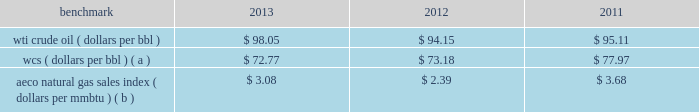Discount to brent was narrower in 2013 than in 2012 and 2011 .
As a result of the significant increase in u.s .
Production of light sweet crude oil , the historical relationship between wti , brent and lls pricing may not be indicative of future periods .
Composition 2013 the proportion of our liquid hydrocarbon sales volumes that are ngls continues to increase due to our development of united states unconventional liquids-rich plays .
Ngls were 15 percent of our north america e&p liquid hydrocarbon sales volumes in 2013 compared to 10 percent in 2012 and 7 percent in 2011 .
Natural gas 2013 a significant portion of our natural gas production in the u.s .
Is sold at bid-week prices , or first-of-month indices relative to our specific producing areas .
Average henry hub settlement prices for natural gas were 31 percent higher for 2013 than for 2012 .
International e&p liquid hydrocarbons 2013 our international e&p crude oil production is relatively sweet and has historically sold in relation to the brent crude benchmark , which on average was 3 percent lower for 2013 than 2012 .
Natural gas 2013 our major international e&p natural gas-producing regions are europe and e.g .
Natural gas prices in europe have been considerably higher than the u.s .
In recent years .
In the case of e.g. , our natural gas sales are subject to term contracts , making realized prices in these areas less volatile .
The natural gas sales from e.g .
Are at fixed prices ; therefore , our reported average international e&p natural gas realized prices may not fully track market price movements .
Oil sands mining the oil sands mining segment produces and sells various qualities of synthetic crude oil .
Output mix can be impacted by operational problems or planned unit outages at the mines or upgrader .
Sales prices for roughly two-thirds of the normal output mix has historically tracked movements in wti and one-third has historically tracked movements in the canadian heavy crude oil marker , primarily wcs .
The wcs discount to wti has been increasing on average in each year presented below .
Despite a wider wcs discount in 2013 , our average oil sands mining price realizations increased due to a greater proportion of higher value synthetic crude oil sales volumes compared to 2012 .
The operating cost structure of the oil sands mining operations is predominantly fixed and therefore many of the costs incurred in times of full operation continue during production downtime .
Per-unit costs are sensitive to production rates .
Key variable costs are natural gas and diesel fuel , which track commodity markets such as the aeco natural gas sales index and crude oil prices , respectively .
The table below shows average benchmark prices that impact both our revenues and variable costs: .
Wcs ( dollars per bbl ) ( a ) $ 72.77 $ 73.18 $ 77.97 aeco natural gas sales index ( dollars per mmbtu ) ( b ) $ 3.08 $ 2.39 $ 3.68 ( a ) monthly pricing based upon average wti adjusted for differentials unique to western canada .
( b ) monthly average day ahead index. .
By what percentage did the aeco natural gas sales index decline from 2011 to 2013? 
Computations: ((3.08 - 3.68) / 3.68)
Answer: -0.16304. 